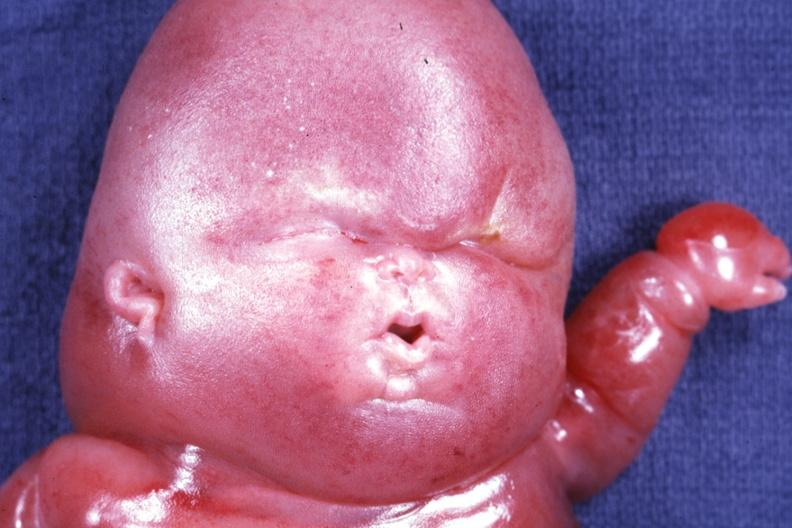s lymphangiomatosis present?
Answer the question using a single word or phrase. Yes 